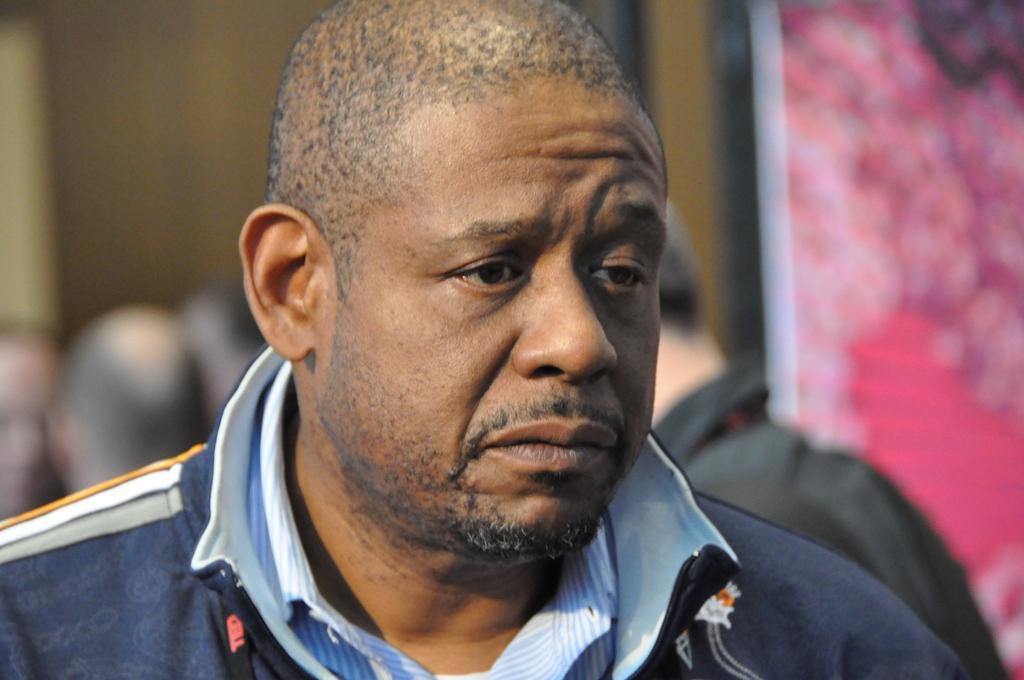Could you give a brief overview of what you see in this image? In this image there is a person in the foreground, in the background there are few peoples visible and the wall, on the right side it might be a colorful wall. 